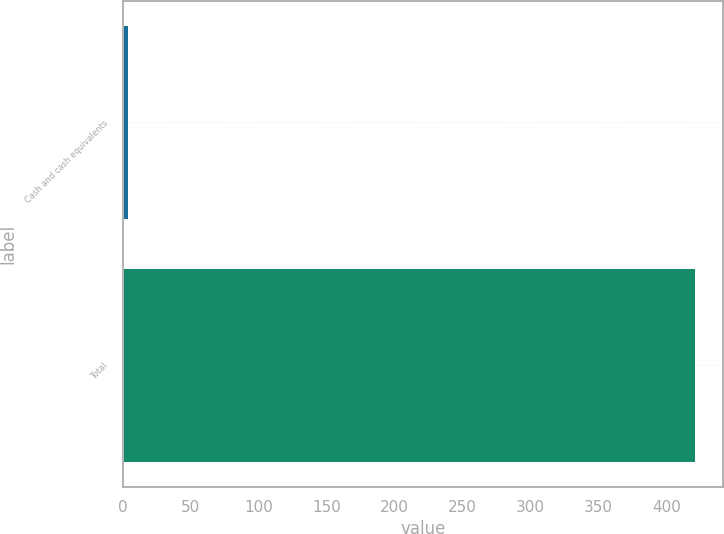Convert chart. <chart><loc_0><loc_0><loc_500><loc_500><bar_chart><fcel>Cash and cash equivalents<fcel>Total<nl><fcel>3.8<fcel>420.6<nl></chart> 